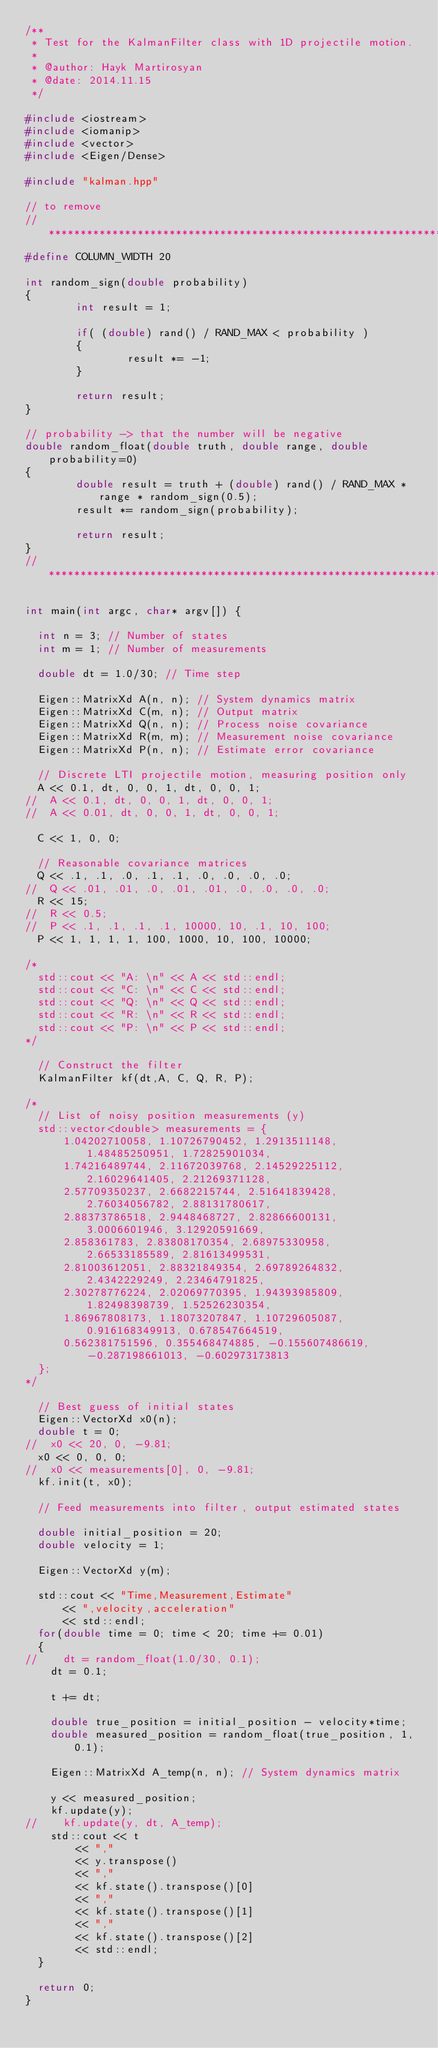Convert code to text. <code><loc_0><loc_0><loc_500><loc_500><_C++_>/**
 * Test for the KalmanFilter class with 1D projectile motion.
 *
 * @author: Hayk Martirosyan
 * @date: 2014.11.15
 */

#include <iostream>
#include <iomanip>
#include <vector>
#include <Eigen/Dense>

#include "kalman.hpp"

// to remove
//************************************************************************************
#define COLUMN_WIDTH 20

int random_sign(double probability)
{
        int result = 1;

        if( (double) rand() / RAND_MAX < probability )
        {
                result *= -1;
        }

        return result;
}

// probability -> that the number will be negative
double random_float(double truth, double range, double probability=0)
{
        double result = truth + (double) rand() / RAND_MAX * range * random_sign(0.5);
        result *= random_sign(probability);

        return result;
}
//************************************************************************************

int main(int argc, char* argv[]) {

  int n = 3; // Number of states
  int m = 1; // Number of measurements

  double dt = 1.0/30; // Time step

  Eigen::MatrixXd A(n, n); // System dynamics matrix
  Eigen::MatrixXd C(m, n); // Output matrix
  Eigen::MatrixXd Q(n, n); // Process noise covariance
  Eigen::MatrixXd R(m, m); // Measurement noise covariance
  Eigen::MatrixXd P(n, n); // Estimate error covariance

  // Discrete LTI projectile motion, measuring position only
  A << 0.1, dt, 0, 0, 1, dt, 0, 0, 1;
//  A << 0.1, dt, 0, 0, 1, dt, 0, 0, 1;
//  A << 0.01, dt, 0, 0, 1, dt, 0, 0, 1;

  C << 1, 0, 0;

  // Reasonable covariance matrices
  Q << .1, .1, .0, .1, .1, .0, .0, .0, .0;
//  Q << .01, .01, .0, .01, .01, .0, .0, .0, .0;
  R << 15;
//  R << 0.5;
//  P << .1, .1, .1, .1, 10000, 10, .1, 10, 100;
  P << 1, 1, 1, 1, 100, 1000, 10, 100, 10000;

/*
  std::cout << "A: \n" << A << std::endl;
  std::cout << "C: \n" << C << std::endl;
  std::cout << "Q: \n" << Q << std::endl;
  std::cout << "R: \n" << R << std::endl;
  std::cout << "P: \n" << P << std::endl;
*/

  // Construct the filter
  KalmanFilter kf(dt,A, C, Q, R, P);

/*
  // List of noisy position measurements (y)
  std::vector<double> measurements = {
      1.04202710058, 1.10726790452, 1.2913511148, 1.48485250951, 1.72825901034,
      1.74216489744, 2.11672039768, 2.14529225112, 2.16029641405, 2.21269371128,
      2.57709350237, 2.6682215744, 2.51641839428, 2.76034056782, 2.88131780617,
      2.88373786518, 2.9448468727, 2.82866600131, 3.0006601946, 3.12920591669,
      2.858361783, 2.83808170354, 2.68975330958, 2.66533185589, 2.81613499531,
      2.81003612051, 2.88321849354, 2.69789264832, 2.4342229249, 2.23464791825,
      2.30278776224, 2.02069770395, 1.94393985809, 1.82498398739, 1.52526230354,
      1.86967808173, 1.18073207847, 1.10729605087, 0.916168349913, 0.678547664519,
      0.562381751596, 0.355468474885, -0.155607486619, -0.287198661013, -0.602973173813
  };
*/

  // Best guess of initial states
  Eigen::VectorXd x0(n);
  double t = 0;
//  x0 << 20, 0, -9.81;
  x0 << 0, 0, 0;
//  x0 << measurements[0], 0, -9.81;
  kf.init(t, x0);

  // Feed measurements into filter, output estimated states

  double initial_position = 20;
  double velocity = 1;

  Eigen::VectorXd y(m);

  std::cout << "Time,Measurement,Estimate"
	    << ",velocity,acceleration"
	    << std::endl;
  for(double time = 0; time < 20; time += 0.01)
  {
//    dt = random_float(1.0/30, 0.1);
    dt = 0.1;

    t += dt;

    double true_position = initial_position - velocity*time;
    double measured_position = random_float(true_position, 1, 0.1);
  
    Eigen::MatrixXd A_temp(n, n); // System dynamics matrix

    y << measured_position;
    kf.update(y);
//    kf.update(y, dt, A_temp);
    std::cout << t
	      << ","
	      << y.transpose()
	      << ","
	      << kf.state().transpose()[0]
	      << ","
	      << kf.state().transpose()[1]
	      << ","
	      << kf.state().transpose()[2]
	      << std::endl;
  }

  return 0;
}
</code> 